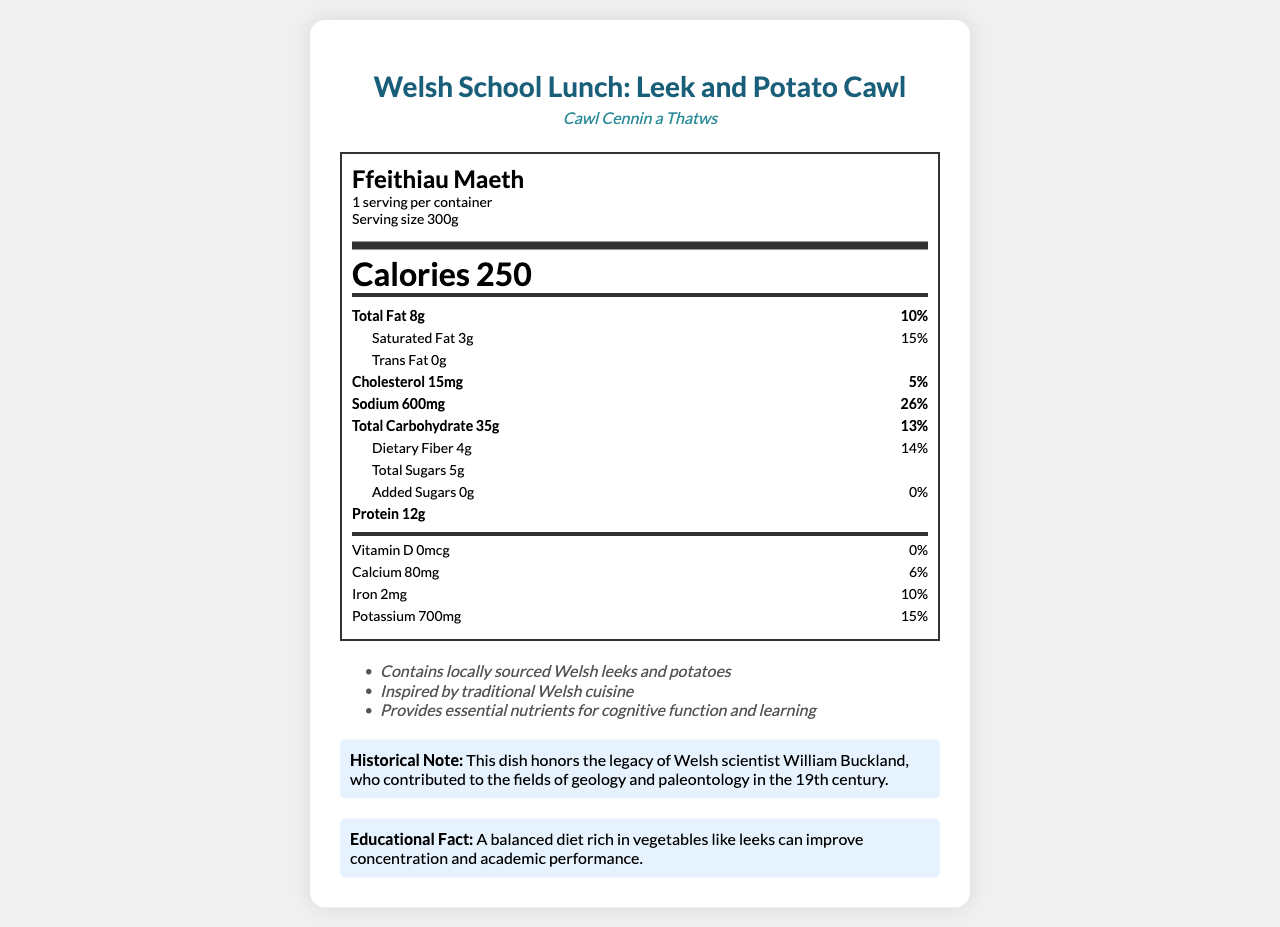what is the serving size for the Welsh School Lunch: Leek and Potato Cawl? The serving size is explicitly stated in the document as 300g.
Answer: 300g how many calories are in one serving? The document lists the calories per serving as 250.
Answer: 250 what percentage of the daily value of total fat does one serving provide? The daily value percentage for total fat is listed as 10%.
Answer: 10% how much dietary fiber is there per serving? The amount of dietary fiber per serving is stated as 4g.
Answer: 4g what historical figure is honored with this dish? The historical note mentions that this dish honors the legacy of the Welsh scientist William Buckland.
Answer: William Buckland how much sodium is in one serving? The sodium content per serving is listed as 600mg.
Answer: 600mg what are the benefits of a diet rich in vegetables like leeks mentioned in the document? The educational fact explains that a balanced diet rich in vegetables like leeks can improve concentration and academic performance.
Answer: improve concentration and academic performance which nutrient does the document mention as having no daily value provided? A. Iron B. Vitamin D C. Calcium The document states that Vitamin D has 0% of the daily value.
Answer: B. Vitamin D how much protein is found in one serving? A. 8g B. 12g C. 15g The document lists 12g of protein per serving.
Answer: B. 12g is the product cholesterol-free? The document shows that the product contains 15mg of cholesterol.
Answer: No does the product contain any added sugars? The document shows that the amount of added sugars is 0g.
Answer: No what is the main idea of the document? The document details the nutritional content, serving size, daily value percentages, historical note, and educational facts related to the Welsh School Lunch.
Answer: The document provides nutritional information for the Welsh School Lunch: Leek and Potato Cawl, emphasizing the balanced nutrition it offers, its cultural significance, and its benefits for cognitive function and learning. is the carbohydrate content higher than the protein content per serving? The total carbohydrate content is 35g, whereas the protein content is 12g, making the carbohydrate content higher.
Answer: Yes how many servings are in one container? The document states that there is 1 serving per container.
Answer: 1 what importance does the document place on calcium? The document mentions the calcium content as 80mg, which provides 6% of the daily value, indicating that calcium is recognized as an important nutrient.
Answer: Calcium is important for health, and one serving provides 6% of the daily value. what is the Welsh name for this dish? The document provides the Welsh name for the dish as "Cawl Cennin a Thatws."
Answer: Cawl Cennin a Thatws how did William Buckland contribute to the fields mentioned in the historical note? The document honors William Buckland but does not provide specific details on his contributions to geology and paleontology.
Answer: Not enough information 